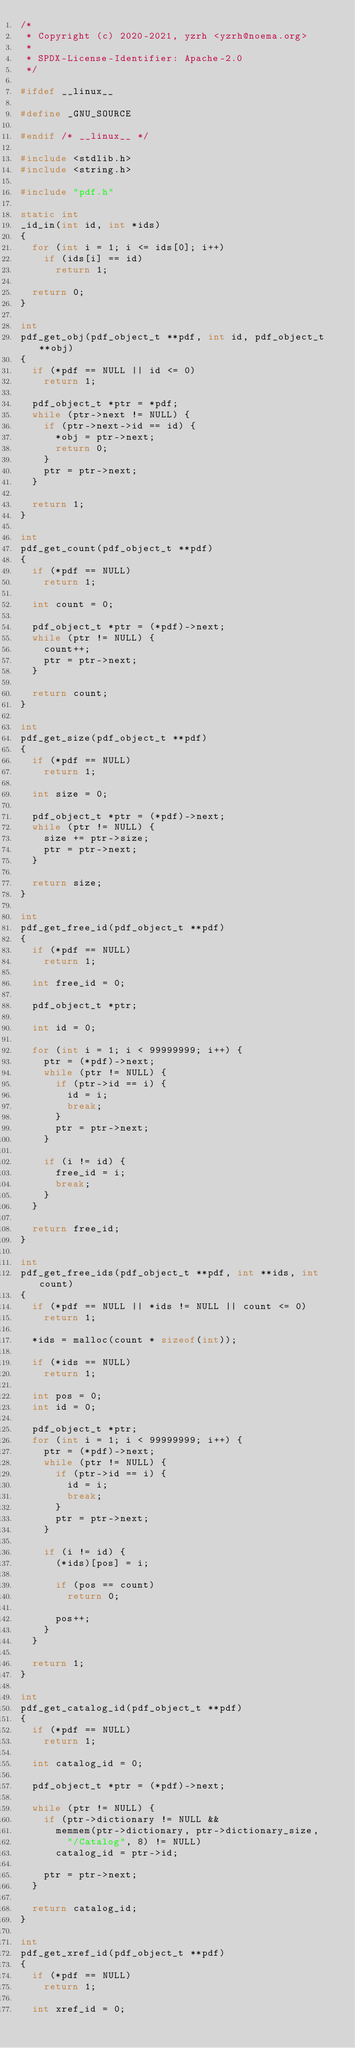<code> <loc_0><loc_0><loc_500><loc_500><_C_>/*
 * Copyright (c) 2020-2021, yzrh <yzrh@noema.org>
 *
 * SPDX-License-Identifier: Apache-2.0
 */

#ifdef __linux__

#define _GNU_SOURCE

#endif /* __linux__ */

#include <stdlib.h>
#include <string.h>

#include "pdf.h"

static int
_id_in(int id, int *ids)
{
	for (int i = 1; i <= ids[0]; i++)
		if (ids[i] == id)
			return 1;

	return 0;
}

int
pdf_get_obj(pdf_object_t **pdf, int id, pdf_object_t **obj)
{
	if (*pdf == NULL || id <= 0)
		return 1;

	pdf_object_t *ptr = *pdf;
	while (ptr->next != NULL) {
		if (ptr->next->id == id) {
			*obj = ptr->next;
			return 0;
		}
		ptr = ptr->next;
	}

	return 1;
}

int
pdf_get_count(pdf_object_t **pdf)
{
	if (*pdf == NULL)
		return 1;

	int count = 0;

	pdf_object_t *ptr = (*pdf)->next;
	while (ptr != NULL) {
		count++;
		ptr = ptr->next;
	}

	return count;
}

int
pdf_get_size(pdf_object_t **pdf)
{
	if (*pdf == NULL)
		return 1;

	int size = 0;

	pdf_object_t *ptr = (*pdf)->next;
	while (ptr != NULL) {
		size += ptr->size;
		ptr = ptr->next;
	}

	return size;
}

int
pdf_get_free_id(pdf_object_t **pdf)
{
	if (*pdf == NULL)
		return 1;

	int free_id = 0;

	pdf_object_t *ptr;

	int id = 0;

	for (int i = 1; i < 99999999; i++) {
		ptr = (*pdf)->next;
		while (ptr != NULL) {
			if (ptr->id == i) {
				id = i;
				break;
			}
			ptr = ptr->next;
		}

		if (i != id) {
			free_id = i;
			break;
		}
	}

	return free_id;
}

int
pdf_get_free_ids(pdf_object_t **pdf, int **ids, int count)
{
	if (*pdf == NULL || *ids != NULL || count <= 0)
		return 1;

	*ids = malloc(count * sizeof(int));

	if (*ids == NULL)
		return 1;

	int pos = 0;
	int id = 0;

	pdf_object_t *ptr;
	for (int i = 1; i < 99999999; i++) {
		ptr = (*pdf)->next;
		while (ptr != NULL) {
			if (ptr->id == i) {
				id = i;
				break;
			}
			ptr = ptr->next;
		}

		if (i != id) {
			(*ids)[pos] = i;

			if (pos == count)
				return 0;

			pos++;
		}
	}

	return 1;
}

int
pdf_get_catalog_id(pdf_object_t **pdf)
{
	if (*pdf == NULL)
		return 1;

	int catalog_id = 0;

	pdf_object_t *ptr = (*pdf)->next;

	while (ptr != NULL) {
		if (ptr->dictionary != NULL &&
			memmem(ptr->dictionary, ptr->dictionary_size,
				"/Catalog", 8) != NULL)
			catalog_id = ptr->id;

		ptr = ptr->next;
	}

	return catalog_id;
}

int
pdf_get_xref_id(pdf_object_t **pdf)
{
	if (*pdf == NULL)
		return 1;

	int xref_id = 0;
</code> 